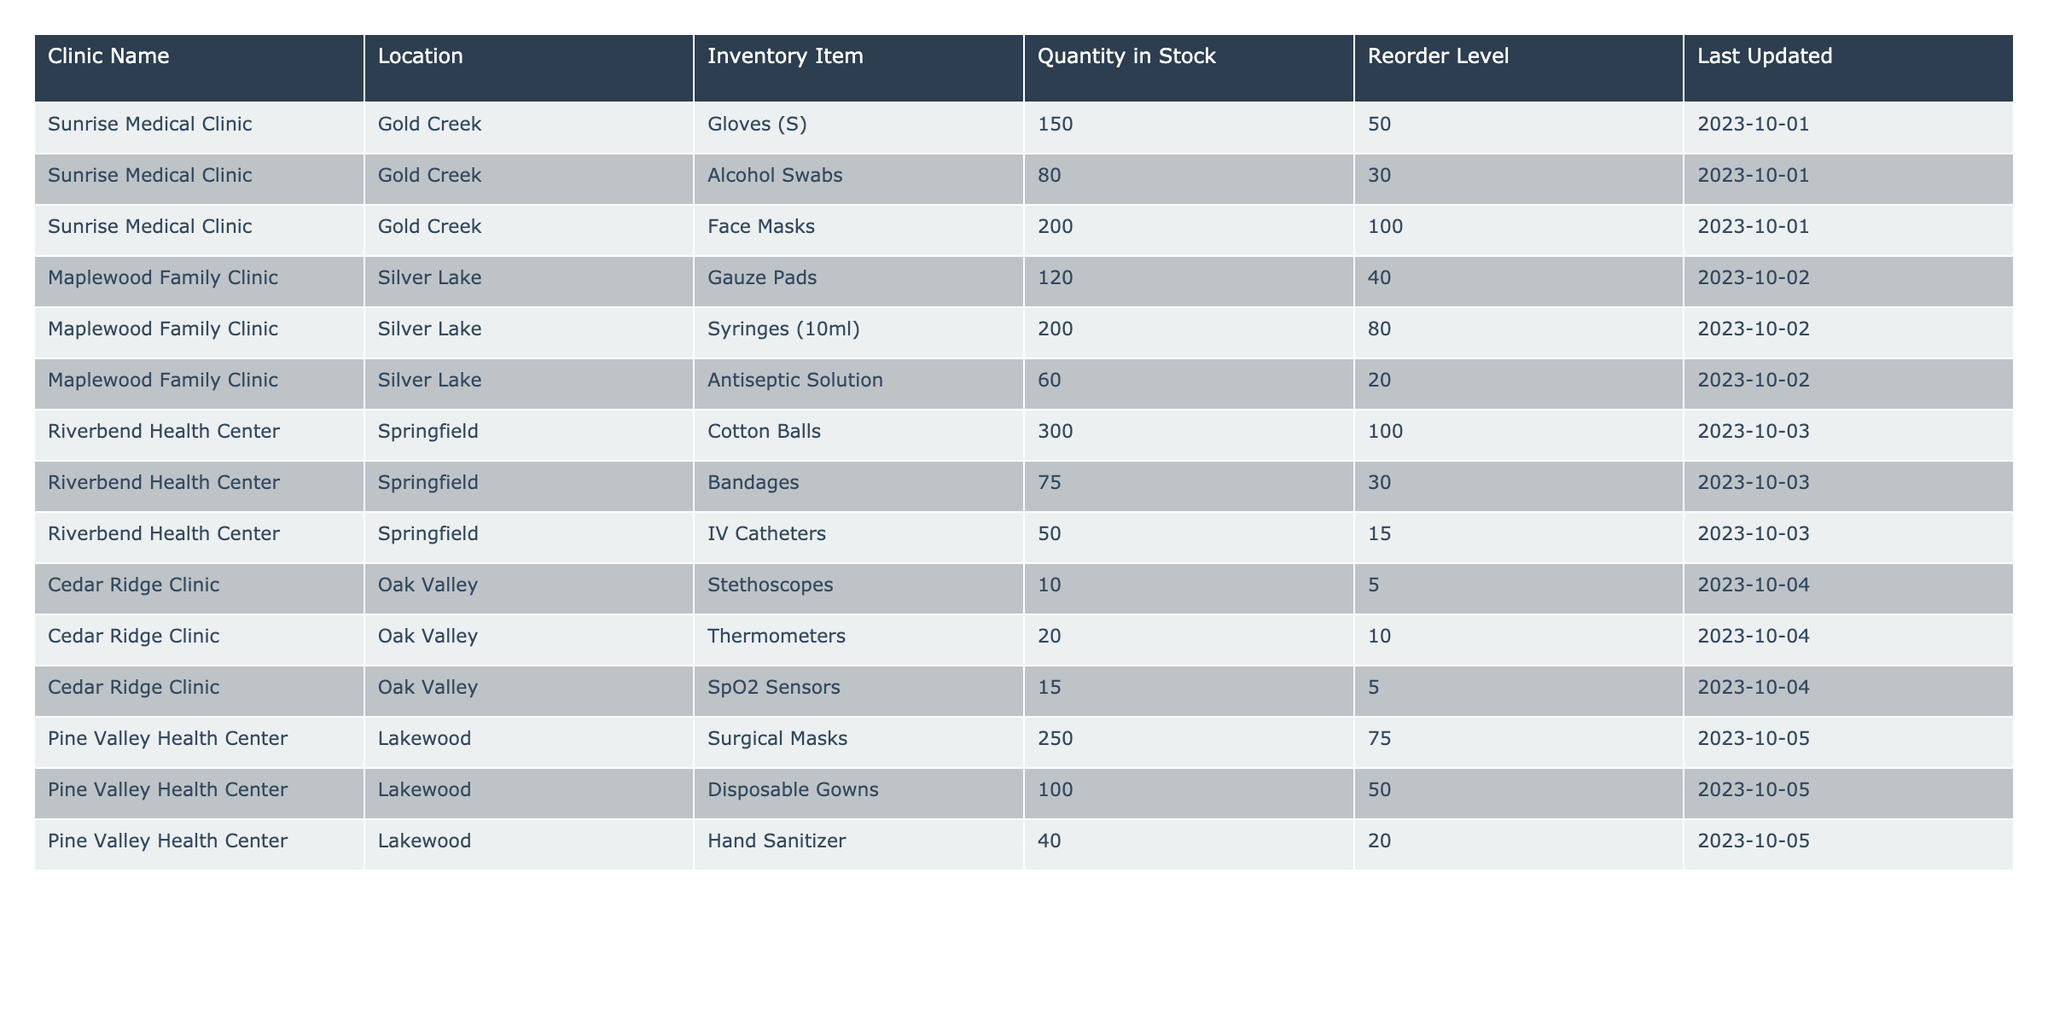What is the quantity in stock of gloves at Sunrise Medical Clinic? Referring to the table, the gloves (S) in stock at Sunrise Medical Clinic show a quantity of 150.
Answer: 150 What is the reorder level for face masks at Sunrise Medical Clinic? The table indicates that the reorder level for face masks at Sunrise Medical Clinic is set at 100.
Answer: 100 Which clinic has the highest quantity in stock for surgical masks? From the table, Pine Valley Health Center has the highest stock for surgical masks, totaling 250.
Answer: Pine Valley Health Center How many more syringes (10ml) are in stock at Maplewood Family Clinic than antiseptic solution? At Maplewood Family Clinic, there are 200 syringes (10ml) and 60 antiseptic solutions. The difference is 200 - 60 = 140.
Answer: 140 Is there any inventory item at Cedar Ridge Clinic that has reached its reorder level? The table shows that stethoscopes (10), thermometers (20), and SpO2 sensors (15) are all at or below their reorder levels (5, 10, and 5 respectively). Therefore, yes, all three items have reached their reorder level.
Answer: Yes What is the total quantity in stock of medical supplies at Riverbend Health Center? The table lists the inventory items at Riverbend Health Center as cotton balls (300), bandages (75), and IV catheters (50). Adding these gives 300 + 75 + 50 = 425.
Answer: 425 Which clinic is updated last according to the table? By reviewing the "Last Updated" column, Riverbend Health Center was last updated on 2023-10-03, while Pine Valley Health Center was last updated on 2023-10-05, making Cedar Ridge Clinic updated last.
Answer: Cedar Ridge Clinic What is the average quantity in stock of gloves and face masks at Sunrise Medical Clinic? The stock for gloves is 150 and for face masks is 200. Adding these gives 150 + 200 = 350. Then, dividing by 2 (the number of items) yields 350 / 2 = 175.
Answer: 175 Which inventory item has the lowest stock across all clinics? The table shows that Cedar Ridge Clinic has the lowest stock of stethoscopes with a quantity of 10, which is less than any other listed supplies.
Answer: Stethoscopes How many total medical supplies exceed their reorder level in the clinics? After reviewing the table, we see gloves, face masks, gauze pads, syringes, cotton balls, disposable gowns, and surgical masks exceed their respective reorder levels. The maximum counts identified show 7 items exceeding their reorder levels.
Answer: 7 